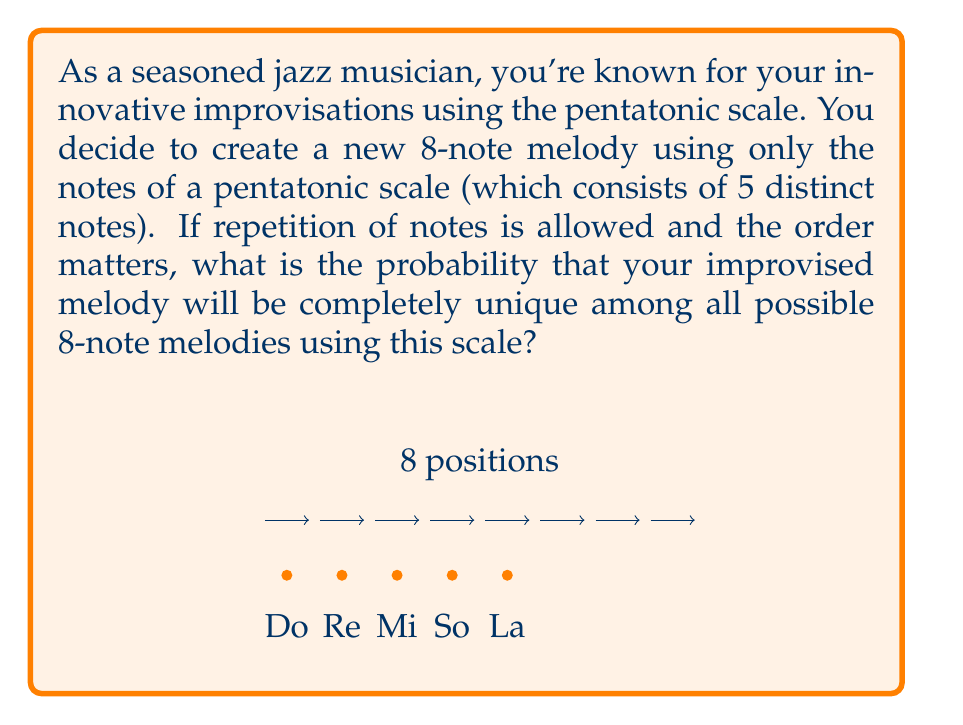Help me with this question. Let's approach this step-by-step:

1) First, we need to calculate the total number of possible 8-note melodies using the pentatonic scale:
   - We have 5 choices for each of the 8 positions in the melody.
   - This is a case of sampling with replacement, where order matters.
   - The total number of possible melodies is therefore:
     $$ 5^8 = 390,625 $$

2) Now, for our improvised melody to be unique, it needs to be different from all other possible melodies.

3) The probability of a unique melody is:
   $$ P(\text{unique}) = \frac{\text{number of favorable outcomes}}{\text{total number of possible outcomes}} $$

4) In this case:
   - There is only 1 favorable outcome (our unique melody)
   - The total number of possible outcomes is $5^8$

5) Therefore, the probability is:
   $$ P(\text{unique}) = \frac{1}{5^8} = \frac{1}{390,625} $$

6) This can be simplified to:
   $$ P(\text{unique}) = 2.56 \times 10^{-6} $$
Answer: $\frac{1}{390,625}$ or $2.56 \times 10^{-6}$ 